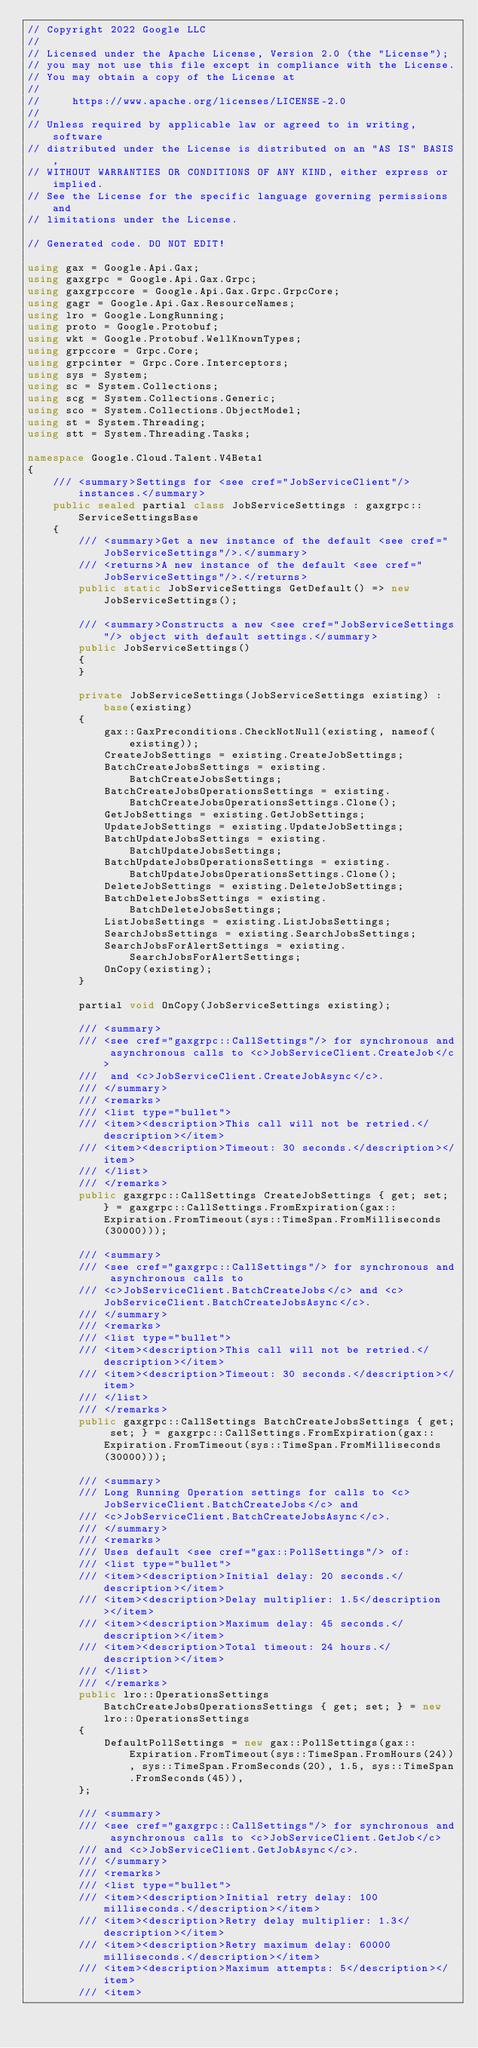Convert code to text. <code><loc_0><loc_0><loc_500><loc_500><_C#_>// Copyright 2022 Google LLC
//
// Licensed under the Apache License, Version 2.0 (the "License");
// you may not use this file except in compliance with the License.
// You may obtain a copy of the License at
//
//     https://www.apache.org/licenses/LICENSE-2.0
//
// Unless required by applicable law or agreed to in writing, software
// distributed under the License is distributed on an "AS IS" BASIS,
// WITHOUT WARRANTIES OR CONDITIONS OF ANY KIND, either express or implied.
// See the License for the specific language governing permissions and
// limitations under the License.

// Generated code. DO NOT EDIT!

using gax = Google.Api.Gax;
using gaxgrpc = Google.Api.Gax.Grpc;
using gaxgrpccore = Google.Api.Gax.Grpc.GrpcCore;
using gagr = Google.Api.Gax.ResourceNames;
using lro = Google.LongRunning;
using proto = Google.Protobuf;
using wkt = Google.Protobuf.WellKnownTypes;
using grpccore = Grpc.Core;
using grpcinter = Grpc.Core.Interceptors;
using sys = System;
using sc = System.Collections;
using scg = System.Collections.Generic;
using sco = System.Collections.ObjectModel;
using st = System.Threading;
using stt = System.Threading.Tasks;

namespace Google.Cloud.Talent.V4Beta1
{
    /// <summary>Settings for <see cref="JobServiceClient"/> instances.</summary>
    public sealed partial class JobServiceSettings : gaxgrpc::ServiceSettingsBase
    {
        /// <summary>Get a new instance of the default <see cref="JobServiceSettings"/>.</summary>
        /// <returns>A new instance of the default <see cref="JobServiceSettings"/>.</returns>
        public static JobServiceSettings GetDefault() => new JobServiceSettings();

        /// <summary>Constructs a new <see cref="JobServiceSettings"/> object with default settings.</summary>
        public JobServiceSettings()
        {
        }

        private JobServiceSettings(JobServiceSettings existing) : base(existing)
        {
            gax::GaxPreconditions.CheckNotNull(existing, nameof(existing));
            CreateJobSettings = existing.CreateJobSettings;
            BatchCreateJobsSettings = existing.BatchCreateJobsSettings;
            BatchCreateJobsOperationsSettings = existing.BatchCreateJobsOperationsSettings.Clone();
            GetJobSettings = existing.GetJobSettings;
            UpdateJobSettings = existing.UpdateJobSettings;
            BatchUpdateJobsSettings = existing.BatchUpdateJobsSettings;
            BatchUpdateJobsOperationsSettings = existing.BatchUpdateJobsOperationsSettings.Clone();
            DeleteJobSettings = existing.DeleteJobSettings;
            BatchDeleteJobsSettings = existing.BatchDeleteJobsSettings;
            ListJobsSettings = existing.ListJobsSettings;
            SearchJobsSettings = existing.SearchJobsSettings;
            SearchJobsForAlertSettings = existing.SearchJobsForAlertSettings;
            OnCopy(existing);
        }

        partial void OnCopy(JobServiceSettings existing);

        /// <summary>
        /// <see cref="gaxgrpc::CallSettings"/> for synchronous and asynchronous calls to <c>JobServiceClient.CreateJob</c>
        ///  and <c>JobServiceClient.CreateJobAsync</c>.
        /// </summary>
        /// <remarks>
        /// <list type="bullet">
        /// <item><description>This call will not be retried.</description></item>
        /// <item><description>Timeout: 30 seconds.</description></item>
        /// </list>
        /// </remarks>
        public gaxgrpc::CallSettings CreateJobSettings { get; set; } = gaxgrpc::CallSettings.FromExpiration(gax::Expiration.FromTimeout(sys::TimeSpan.FromMilliseconds(30000)));

        /// <summary>
        /// <see cref="gaxgrpc::CallSettings"/> for synchronous and asynchronous calls to
        /// <c>JobServiceClient.BatchCreateJobs</c> and <c>JobServiceClient.BatchCreateJobsAsync</c>.
        /// </summary>
        /// <remarks>
        /// <list type="bullet">
        /// <item><description>This call will not be retried.</description></item>
        /// <item><description>Timeout: 30 seconds.</description></item>
        /// </list>
        /// </remarks>
        public gaxgrpc::CallSettings BatchCreateJobsSettings { get; set; } = gaxgrpc::CallSettings.FromExpiration(gax::Expiration.FromTimeout(sys::TimeSpan.FromMilliseconds(30000)));

        /// <summary>
        /// Long Running Operation settings for calls to <c>JobServiceClient.BatchCreateJobs</c> and
        /// <c>JobServiceClient.BatchCreateJobsAsync</c>.
        /// </summary>
        /// <remarks>
        /// Uses default <see cref="gax::PollSettings"/> of:
        /// <list type="bullet">
        /// <item><description>Initial delay: 20 seconds.</description></item>
        /// <item><description>Delay multiplier: 1.5</description></item>
        /// <item><description>Maximum delay: 45 seconds.</description></item>
        /// <item><description>Total timeout: 24 hours.</description></item>
        /// </list>
        /// </remarks>
        public lro::OperationsSettings BatchCreateJobsOperationsSettings { get; set; } = new lro::OperationsSettings
        {
            DefaultPollSettings = new gax::PollSettings(gax::Expiration.FromTimeout(sys::TimeSpan.FromHours(24)), sys::TimeSpan.FromSeconds(20), 1.5, sys::TimeSpan.FromSeconds(45)),
        };

        /// <summary>
        /// <see cref="gaxgrpc::CallSettings"/> for synchronous and asynchronous calls to <c>JobServiceClient.GetJob</c>
        /// and <c>JobServiceClient.GetJobAsync</c>.
        /// </summary>
        /// <remarks>
        /// <list type="bullet">
        /// <item><description>Initial retry delay: 100 milliseconds.</description></item>
        /// <item><description>Retry delay multiplier: 1.3</description></item>
        /// <item><description>Retry maximum delay: 60000 milliseconds.</description></item>
        /// <item><description>Maximum attempts: 5</description></item>
        /// <item></code> 